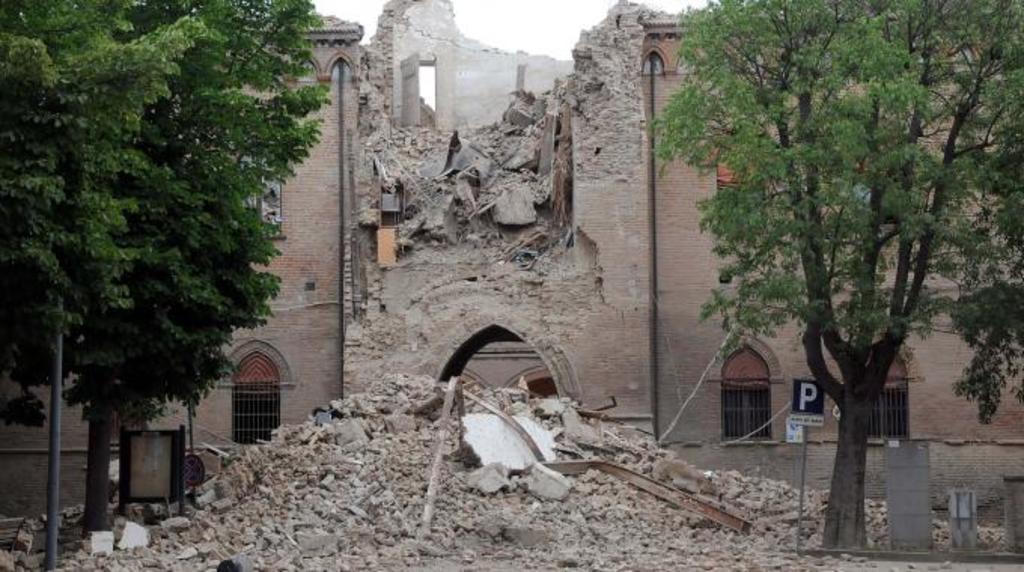Could you give a brief overview of what you see in this image? In this image we can see a collapsed building, in front of the building there are trees, an iron pole and a sign board. 